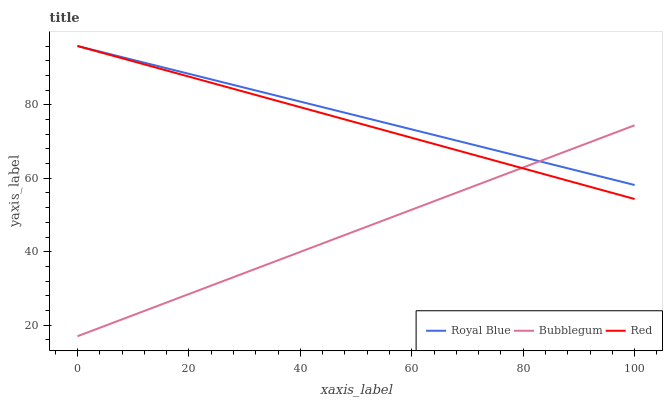Does Red have the minimum area under the curve?
Answer yes or no. No. Does Red have the maximum area under the curve?
Answer yes or no. No. Is Red the smoothest?
Answer yes or no. No. Is Red the roughest?
Answer yes or no. No. Does Red have the lowest value?
Answer yes or no. No. Does Bubblegum have the highest value?
Answer yes or no. No. 